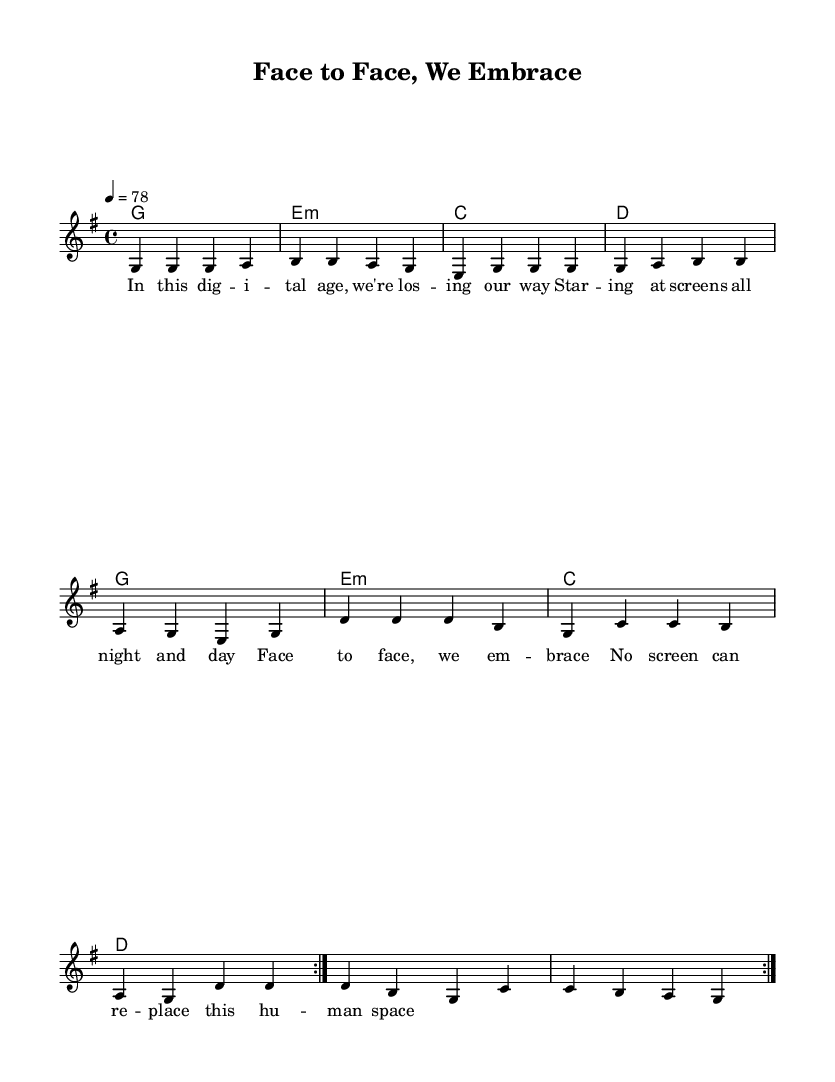What is the key signature of this music? The key signature is G major, which has one sharp (F#).
Answer: G major What is the time signature of this music? The time signature is 4/4, indicating four beats in a measure.
Answer: 4/4 What is the tempo marking for this piece? The tempo marking indicates a speed of 78 beats per minute, typically felt as a moderate pace.
Answer: 78 How many times is the volta repeated in the melody? The melody has a repeat sign indicating it is played two times before moving on.
Answer: 2 What lyrical theme is present in the text? The lyrics express a longing for face-to-face interactions over digital communication, emphasizing the importance of personal connections.
Answer: Human space What chords are used in the piece? The chords consist of G major, E minor, C major, and D major, which are common in reggae music, providing a relaxed and uplifting feel.
Answer: G, E:min, C, D 